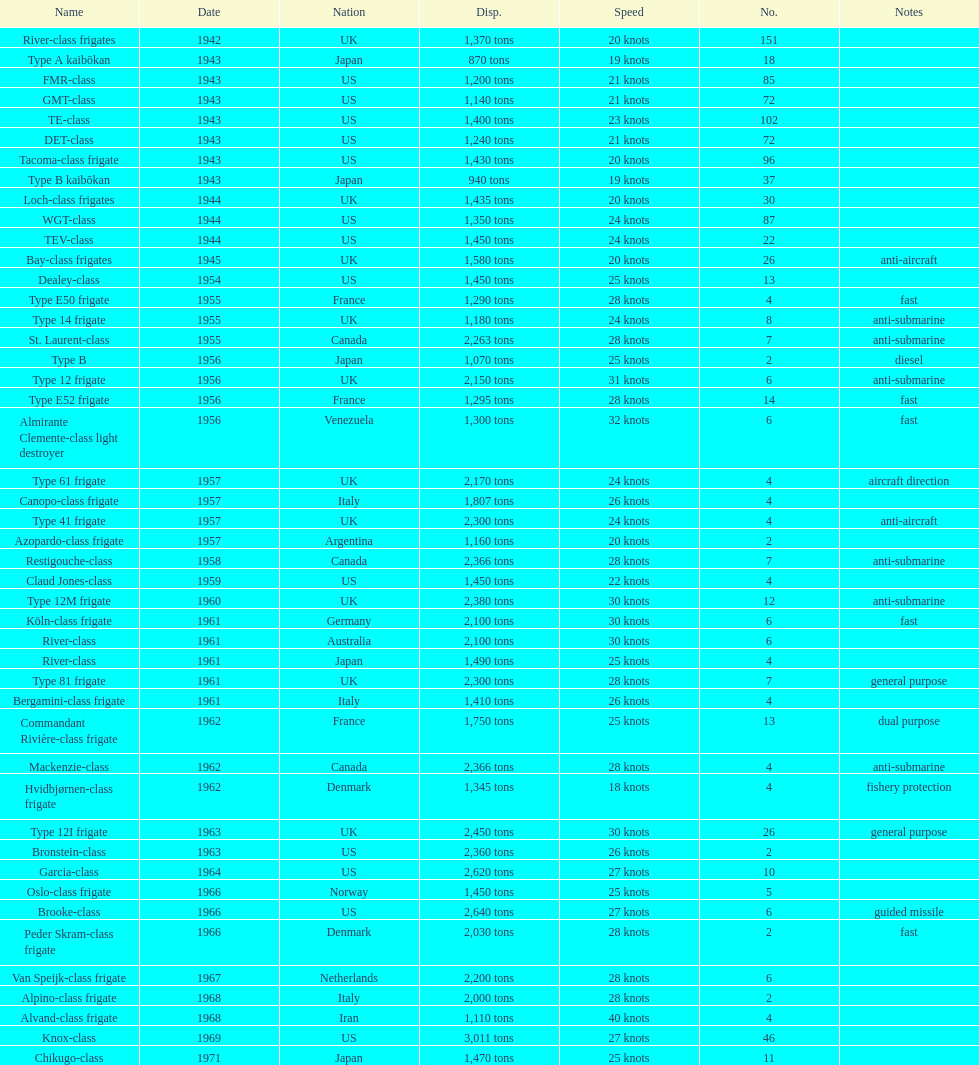How many tons does the te-class displace? 1,400 tons. 